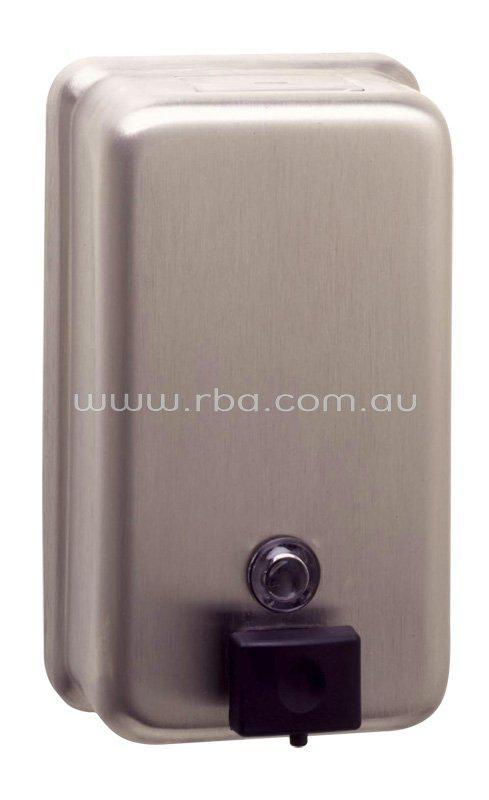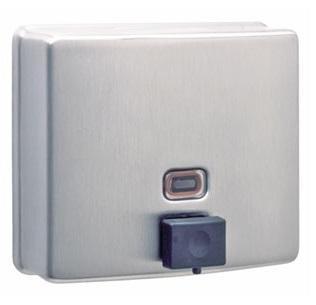The first image is the image on the left, the second image is the image on the right. Considering the images on both sides, is "The left image features a narrower rectangular dispenser with a circle above a dark rectangular button, and the right image features a more square dispenser with a rectangle above the rectangular button on the bottom." valid? Answer yes or no. Yes. The first image is the image on the left, the second image is the image on the right. Analyze the images presented: Is the assertion "The left and right image contains the same number of metal wall soap dispensers." valid? Answer yes or no. Yes. 